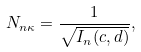Convert formula to latex. <formula><loc_0><loc_0><loc_500><loc_500>N _ { n \kappa } = \frac { 1 } { \sqrt { I _ { n } ( c , d ) } } ,</formula> 